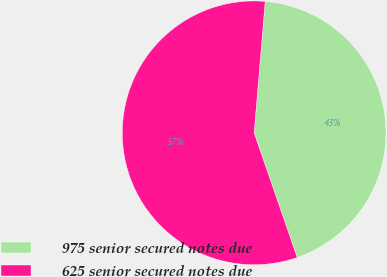<chart> <loc_0><loc_0><loc_500><loc_500><pie_chart><fcel>975 senior secured notes due<fcel>625 senior secured notes due<nl><fcel>43.37%<fcel>56.63%<nl></chart> 